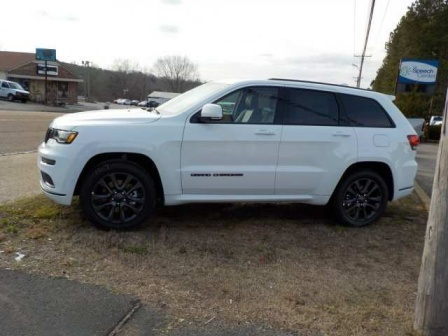Describe the scene and the setting in detail. The scene depicts a white Jeep Grand Cherokee parked on a patch of grass next to a road. The ground is a mix of grassy and dry patches, indicating it might be late autumn or early spring. The SUV's black rims and polished exterior suggest it is well-maintained. In the background, there is a small building with a brown roof, possibly a local shop or office, and a blue sign that might provide directions or local information. The area seems quiet and sparsely populated, with a few trees without leaves, hinting at a rural or suburban environment with a calm and peaceful ambiance. 